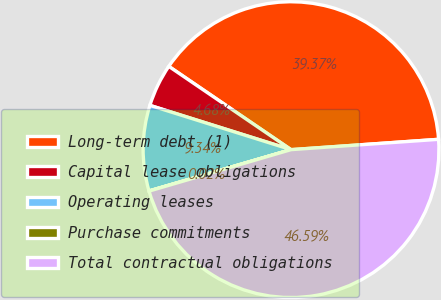<chart> <loc_0><loc_0><loc_500><loc_500><pie_chart><fcel>Long-term debt (1)<fcel>Capital lease obligations<fcel>Operating leases<fcel>Purchase commitments<fcel>Total contractual obligations<nl><fcel>39.37%<fcel>4.68%<fcel>9.34%<fcel>0.02%<fcel>46.59%<nl></chart> 